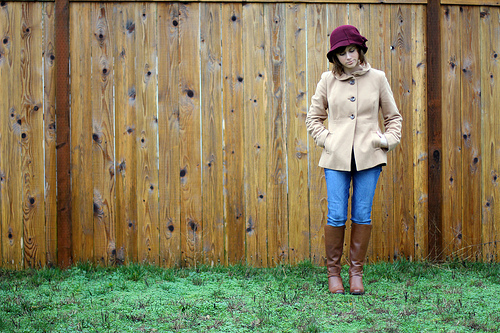<image>
Is the wood on the grass? Yes. Looking at the image, I can see the wood is positioned on top of the grass, with the grass providing support. Is there a brown jacket behind the gate? No. The brown jacket is not behind the gate. From this viewpoint, the brown jacket appears to be positioned elsewhere in the scene. 